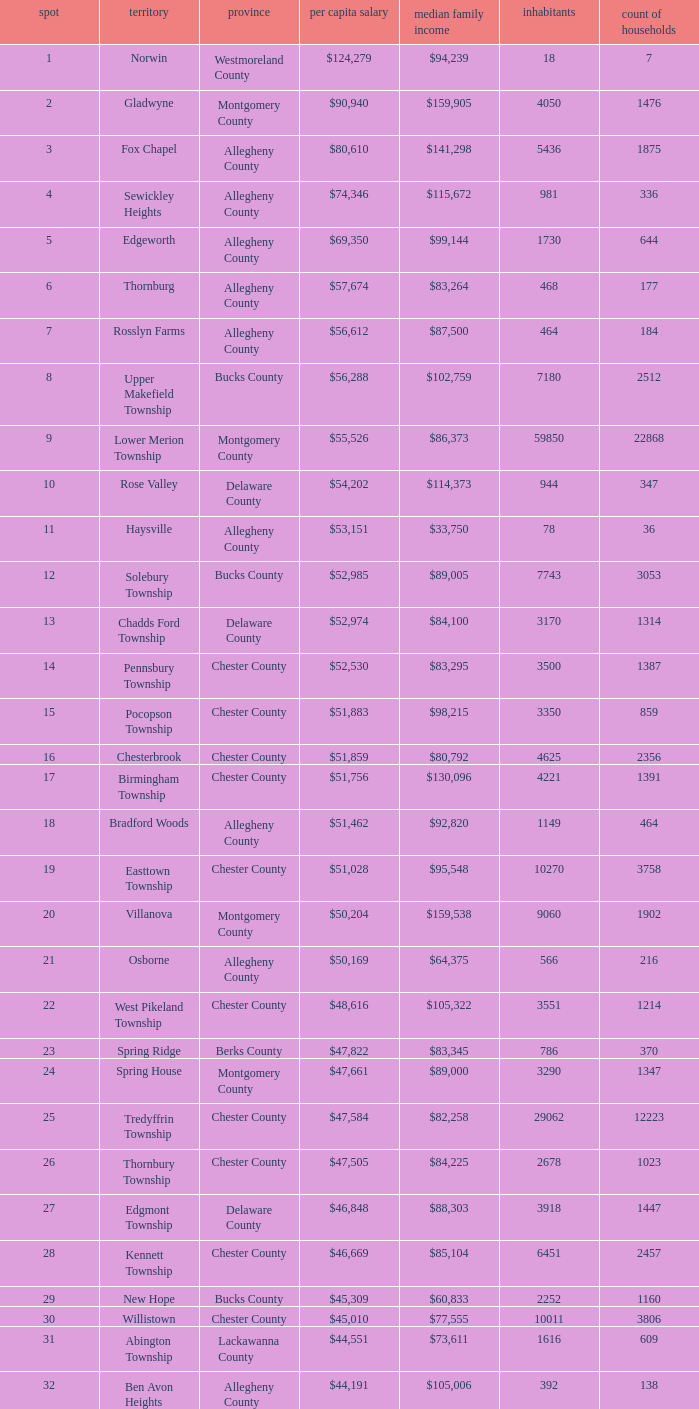Which place has a rank of 71? Wyomissing. Parse the full table. {'header': ['spot', 'territory', 'province', 'per capita salary', 'median family income', 'inhabitants', 'count of households'], 'rows': [['1', 'Norwin', 'Westmoreland County', '$124,279', '$94,239', '18', '7'], ['2', 'Gladwyne', 'Montgomery County', '$90,940', '$159,905', '4050', '1476'], ['3', 'Fox Chapel', 'Allegheny County', '$80,610', '$141,298', '5436', '1875'], ['4', 'Sewickley Heights', 'Allegheny County', '$74,346', '$115,672', '981', '336'], ['5', 'Edgeworth', 'Allegheny County', '$69,350', '$99,144', '1730', '644'], ['6', 'Thornburg', 'Allegheny County', '$57,674', '$83,264', '468', '177'], ['7', 'Rosslyn Farms', 'Allegheny County', '$56,612', '$87,500', '464', '184'], ['8', 'Upper Makefield Township', 'Bucks County', '$56,288', '$102,759', '7180', '2512'], ['9', 'Lower Merion Township', 'Montgomery County', '$55,526', '$86,373', '59850', '22868'], ['10', 'Rose Valley', 'Delaware County', '$54,202', '$114,373', '944', '347'], ['11', 'Haysville', 'Allegheny County', '$53,151', '$33,750', '78', '36'], ['12', 'Solebury Township', 'Bucks County', '$52,985', '$89,005', '7743', '3053'], ['13', 'Chadds Ford Township', 'Delaware County', '$52,974', '$84,100', '3170', '1314'], ['14', 'Pennsbury Township', 'Chester County', '$52,530', '$83,295', '3500', '1387'], ['15', 'Pocopson Township', 'Chester County', '$51,883', '$98,215', '3350', '859'], ['16', 'Chesterbrook', 'Chester County', '$51,859', '$80,792', '4625', '2356'], ['17', 'Birmingham Township', 'Chester County', '$51,756', '$130,096', '4221', '1391'], ['18', 'Bradford Woods', 'Allegheny County', '$51,462', '$92,820', '1149', '464'], ['19', 'Easttown Township', 'Chester County', '$51,028', '$95,548', '10270', '3758'], ['20', 'Villanova', 'Montgomery County', '$50,204', '$159,538', '9060', '1902'], ['21', 'Osborne', 'Allegheny County', '$50,169', '$64,375', '566', '216'], ['22', 'West Pikeland Township', 'Chester County', '$48,616', '$105,322', '3551', '1214'], ['23', 'Spring Ridge', 'Berks County', '$47,822', '$83,345', '786', '370'], ['24', 'Spring House', 'Montgomery County', '$47,661', '$89,000', '3290', '1347'], ['25', 'Tredyffrin Township', 'Chester County', '$47,584', '$82,258', '29062', '12223'], ['26', 'Thornbury Township', 'Chester County', '$47,505', '$84,225', '2678', '1023'], ['27', 'Edgmont Township', 'Delaware County', '$46,848', '$88,303', '3918', '1447'], ['28', 'Kennett Township', 'Chester County', '$46,669', '$85,104', '6451', '2457'], ['29', 'New Hope', 'Bucks County', '$45,309', '$60,833', '2252', '1160'], ['30', 'Willistown', 'Chester County', '$45,010', '$77,555', '10011', '3806'], ['31', 'Abington Township', 'Lackawanna County', '$44,551', '$73,611', '1616', '609'], ['32', 'Ben Avon Heights', 'Allegheny County', '$44,191', '$105,006', '392', '138'], ['33', 'Bala-Cynwyd', 'Montgomery County', '$44,027', '$78,932', '9336', '3726'], ['34', 'Lower Makefield Township', 'Bucks County', '$43,983', '$98,090', '32681', '11706'], ['35', 'Blue Bell', 'Montgomery County', '$43,813', '$94,160', '6395', '2434'], ['36', 'West Vincent Township', 'Chester County', '$43,500', '$92,024', '3170', '1077'], ['37', 'Mount Gretna', 'Lebanon County', '$43,470', '$62,917', '242', '117'], ['38', 'Schuylkill Township', 'Chester County', '$43,379', '$86,092', '6960', '2536'], ['39', 'Fort Washington', 'Montgomery County', '$43,090', '$103,469', '3680', '1161'], ['40', 'Marshall Township', 'Allegheny County', '$42,856', '$102,351', '5996', '1944'], ['41', 'Woodside', 'Bucks County', '$42,653', '$121,151', '2575', '791'], ['42', 'Wrightstown Township', 'Bucks County', '$42,623', '$82,875', '2839', '971'], ['43', 'Upper St.Clair Township', 'Allegheny County', '$42,413', '$87,581', '20053', '6966'], ['44', 'Seven Springs', 'Fayette County', '$42,131', '$48,750', '127', '63'], ['45', 'Charlestown Township', 'Chester County', '$41,878', '$89,813', '4051', '1340'], ['46', 'Lower Gwynedd Township', 'Montgomery County', '$41,868', '$74,351', '10422', '4177'], ['47', 'Whitpain Township', 'Montgomery County', '$41,739', '$88,933', '18562', '6960'], ['48', 'Bell Acres', 'Allegheny County', '$41,202', '$61,094', '1382', '520'], ['49', 'Penn Wynne', 'Montgomery County', '$41,199', '$78,398', '5382', '2072'], ['50', 'East Bradford Township', 'Chester County', '$41,158', '$100,732', '9405', '3076'], ['51', 'Swarthmore', 'Delaware County', '$40,482', '$82,653', '6170', '1993'], ['52', 'Lafayette Hill', 'Montgomery County', '$40,363', '$84,835', '10226', '3783'], ['53', 'Lower Moreland Township', 'Montgomery County', '$40,129', '$82,597', '11281', '4112'], ['54', 'Radnor Township', 'Delaware County', '$39,813', '$74,272', '30878', '10347'], ['55', 'Whitemarsh Township', 'Montgomery County', '$39,785', '$78,630', '16702', '6179'], ['56', 'Upper Providence Township', 'Delaware County', '$39,532', '$71,166', '10509', '4075'], ['57', 'Newtown Township', 'Delaware County', '$39,364', '$65,924', '11700', '4549'], ['58', 'Adams Township', 'Butler County', '$39,204', '$65,357', '6774', '2382'], ['59', 'Edgewood', 'Allegheny County', '$39,188', '$52,153', '3311', '1639'], ['60', 'Dresher', 'Montgomery County', '$38,865', '$99,231', '5610', '1765'], ['61', 'Sewickley Hills', 'Allegheny County', '$38,681', '$79,466', '652', '225'], ['62', 'Exton', 'Chester County', '$38,589', '$68,240', '4267', '2053'], ['63', 'East Marlborough Township', 'Chester County', '$38,090', '$95,812', '6317', '2131'], ['64', 'Doylestown Township', 'Bucks County', '$38,031', '$81,226', '17619', '5999'], ['65', 'Upper Dublin Township', 'Montgomery County', '$37,994', '$80,093', '25878', '9174'], ['66', 'Churchill', 'Allegheny County', '$37,964', '$67,321', '3566', '1519'], ['67', 'Franklin Park', 'Allegheny County', '$37,924', '$87,627', '11364', '3866'], ['68', 'East Goshen Township', 'Chester County', '$37,775', '$64,777', '16824', '7165'], ['69', 'Chester Heights', 'Delaware County', '$37,707', '$70,236', '2481', '1056'], ['70', 'McMurray', 'Washington County', '$37,364', '$81,736', '4726', '1582'], ['71', 'Wyomissing', 'Berks County', '$37,313', '$54,681', '8587', '3359'], ['72', 'Heath Township', 'Jefferson County', '$37,309', '$42,500', '160', '77'], ['73', 'Aleppo Township', 'Allegheny County', '$37,187', '$59,167', '1039', '483'], ['74', 'Westtown Township', 'Chester County', '$36,894', '$85,049', '10352', '3705'], ['75', 'Thompsonville', 'Washington County', '$36,853', '$75,000', '3592', '1228'], ['76', 'Flying Hills', 'Berks County', '$36,822', '$59,596', '1191', '592'], ['77', 'Newlin Township', 'Chester County', '$36,804', '$68,828', '1150', '429'], ['78', 'Wyndmoor', 'Montgomery County', '$36,205', '$72,219', '5601', '2144'], ['79', 'Peters Township', 'Washington County', '$36,159', '$77,442', '17566', '6026'], ['80', 'Ardmore', 'Montgomery County', '$36,111', '$60,966', '12616', '5529'], ['81', 'Clarks Green', 'Lackawanna County', '$35,975', '$61,250', '1630', '616'], ['82', 'London Britain Township', 'Chester County', '$35,761', '$93,521', '2797', '957'], ['83', 'Buckingham Township', 'Bucks County', '$35,735', '$82,376', '16422', '5711'], ['84', 'Devon-Berwyn', 'Chester County', '$35,551', '$74,886', '5067', '1978'], ['85', 'North Abington Township', 'Lackawanna County', '$35,537', '$57,917', '782', '258'], ['86', 'Malvern', 'Chester County', '$35,477', '$62,308', '3059', '1361'], ['87', 'Pine Township', 'Allegheny County', '$35,202', '$85,817', '7683', '2411'], ['88', 'Narberth', 'Montgomery County', '$35,165', '$60,408', '4233', '1904'], ['89', 'West Whiteland Township', 'Chester County', '$35,031', '$71,545', '16499', '6618'], ['90', 'Timber Hills', 'Lebanon County', '$34,974', '$55,938', '329', '157'], ['91', 'Upper Merion Township', 'Montgomery County', '$34,961', '$65,636', '26863', '11575'], ['92', 'Homewood', 'Beaver County', '$34,486', '$33,333', '147', '59'], ['93', 'Newtown Township', 'Bucks County', '$34,335', '$80,532', '18206', '6761'], ['94', 'Tinicum Township', 'Bucks County', '$34,321', '$60,843', '4206', '1674'], ['95', 'Worcester Township', 'Montgomery County', '$34,264', '$77,200', '7789', '2896'], ['96', 'Wyomissing Hills', 'Berks County', '$34,024', '$61,364', '2568', '986'], ['97', 'Woodbourne', 'Bucks County', '$33,821', '$107,913', '3512', '1008'], ['98', 'Concord Township', 'Delaware County', '$33,800', '$85,503', '9933', '3384'], ['99', 'Uwchlan Township', 'Chester County', '$33,785', '$81,985', '16576', '5921']]} 